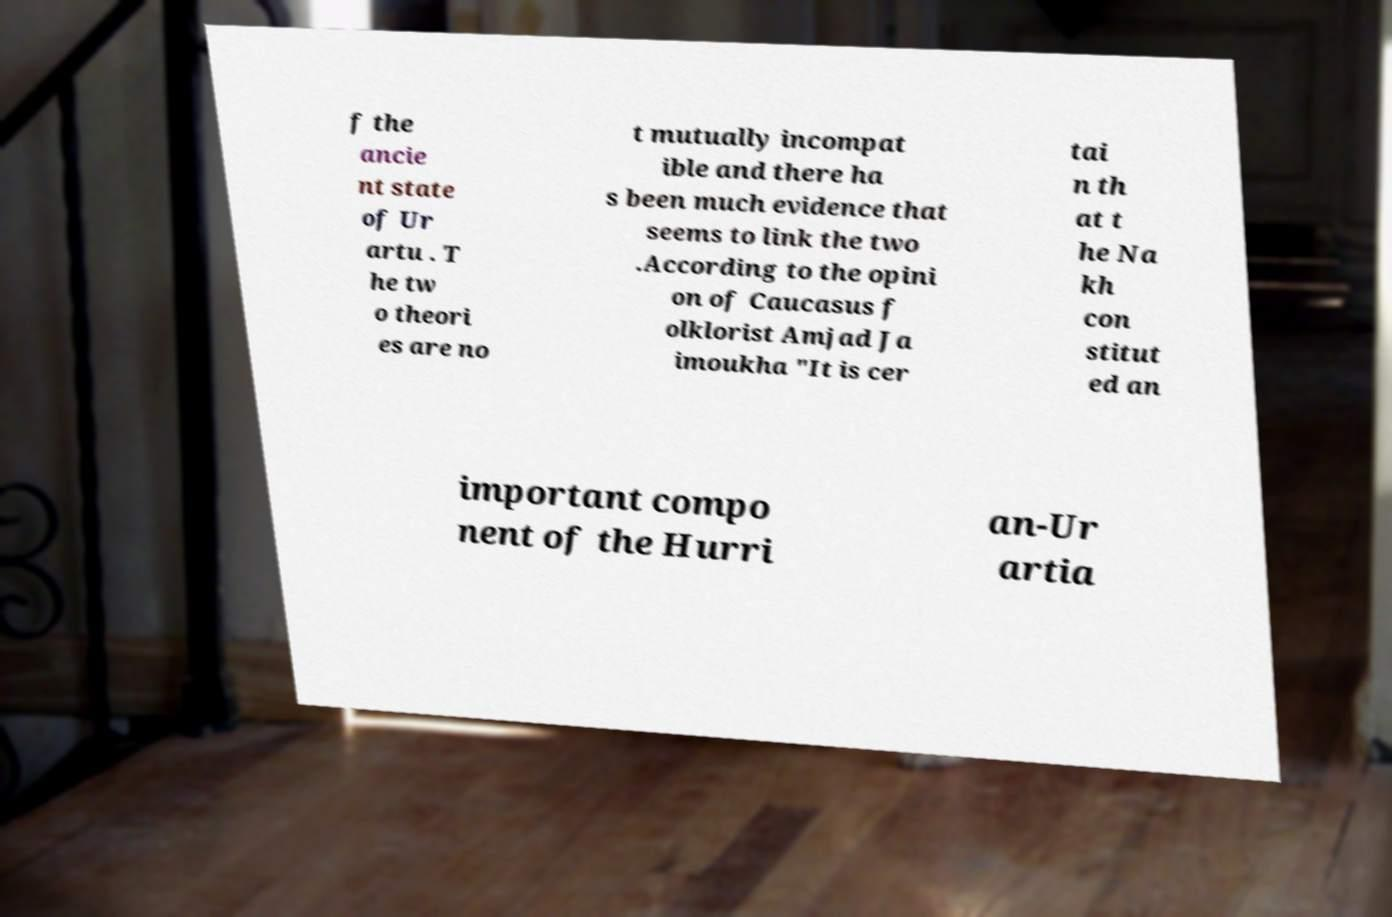Could you extract and type out the text from this image? f the ancie nt state of Ur artu . T he tw o theori es are no t mutually incompat ible and there ha s been much evidence that seems to link the two .According to the opini on of Caucasus f olklorist Amjad Ja imoukha "It is cer tai n th at t he Na kh con stitut ed an important compo nent of the Hurri an-Ur artia 